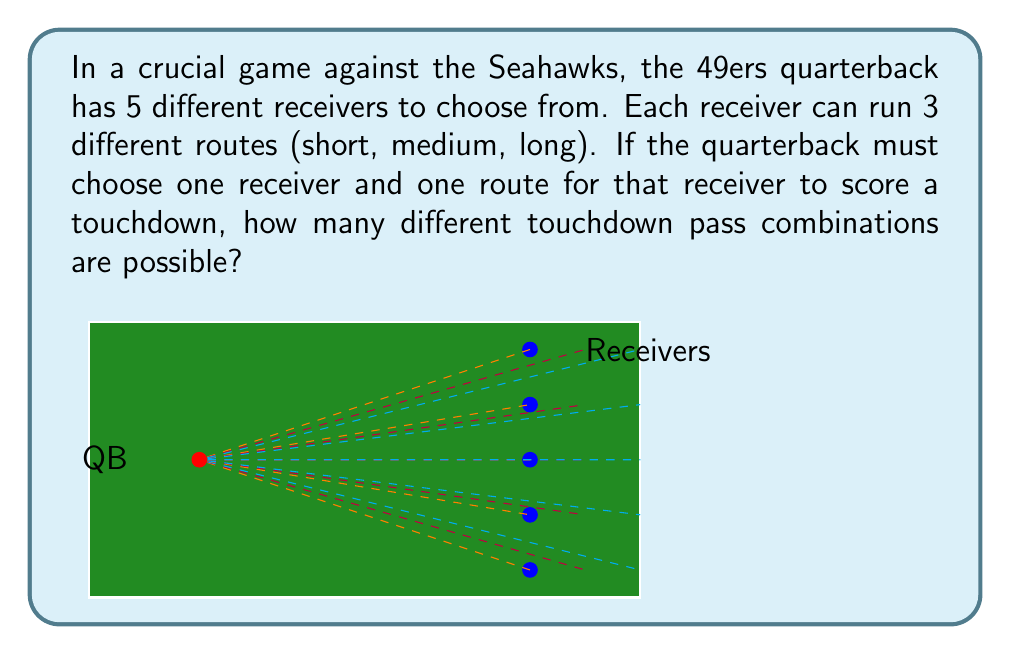Give your solution to this math problem. To solve this problem, we can use the multiplication principle of counting. We need to consider two independent choices:

1. Choosing a receiver
2. Choosing a route for that receiver

Let's break it down step-by-step:

1. Number of ways to choose a receiver:
   - There are 5 different receivers to choose from.

2. Number of ways to choose a route:
   - For each receiver, there are 3 different routes (short, medium, long).

According to the multiplication principle, when we have two independent choices, we multiply the number of options for each choice:

$$ \text{Total combinations} = \text{Number of receivers} \times \text{Number of routes} $$

$$ \text{Total combinations} = 5 \times 3 = 15 $$

Therefore, there are 15 different touchdown pass combinations possible.

This can also be thought of as a simple application of the fundamental counting principle:

$$ n(\text{A} \times \text{B}) = n(\text{A}) \times n(\text{B}) $$

Where A is the set of receivers and B is the set of routes.
Answer: 15 combinations 